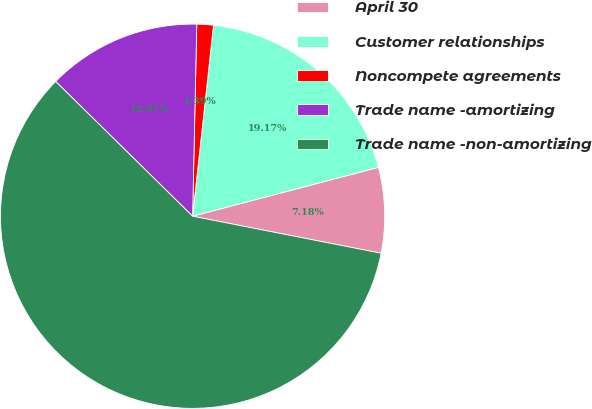Convert chart. <chart><loc_0><loc_0><loc_500><loc_500><pie_chart><fcel>April 30<fcel>Customer relationships<fcel>Noncompete agreements<fcel>Trade name -amortizing<fcel>Trade name -non-amortizing<nl><fcel>7.18%<fcel>19.17%<fcel>1.39%<fcel>12.97%<fcel>59.28%<nl></chart> 